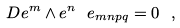<formula> <loc_0><loc_0><loc_500><loc_500>D e ^ { m } \wedge e ^ { n } \ e _ { m n p q } = 0 \ ,</formula> 